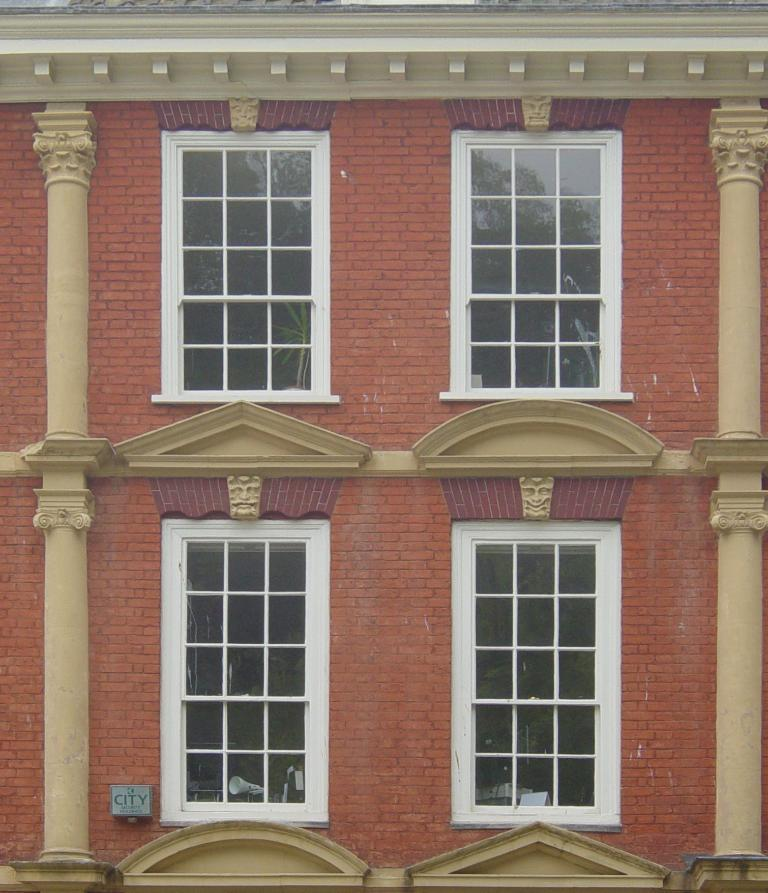What type of structure is visible in the image? There is a building in the image. What architectural features can be seen on the sides of the building? There are pillars on either side of the image. How many windows are present in the building? There are four windows in the building. What type of shoes are being worn by the lift in the image? There is no lift present in the image, and therefore no shoes to be worn. 